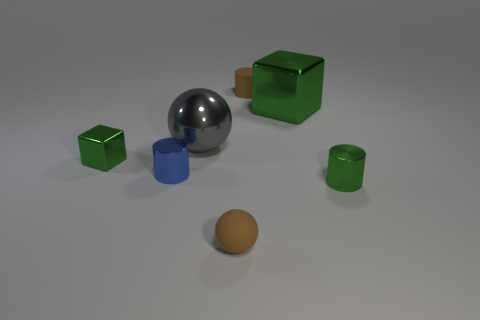There is a small brown matte object that is in front of the metallic cylinder on the right side of the small ball; what shape is it?
Ensure brevity in your answer.  Sphere. How many objects are tiny shiny cylinders that are on the right side of the large cube or tiny metallic things left of the gray sphere?
Your answer should be compact. 3. What is the shape of the large gray thing that is made of the same material as the green cylinder?
Keep it short and to the point. Sphere. Are there any other things of the same color as the large sphere?
Offer a terse response. No. What is the material of the tiny brown thing that is the same shape as the big gray thing?
Provide a short and direct response. Rubber. What number of other things are there of the same size as the blue shiny object?
Provide a short and direct response. 4. What is the material of the big green thing?
Provide a succinct answer. Metal. Is the number of green shiny things to the left of the small green shiny cylinder greater than the number of tiny brown balls?
Your response must be concise. Yes. Are there any gray cylinders?
Offer a terse response. No. How many other objects are there of the same shape as the large green object?
Offer a terse response. 1. 